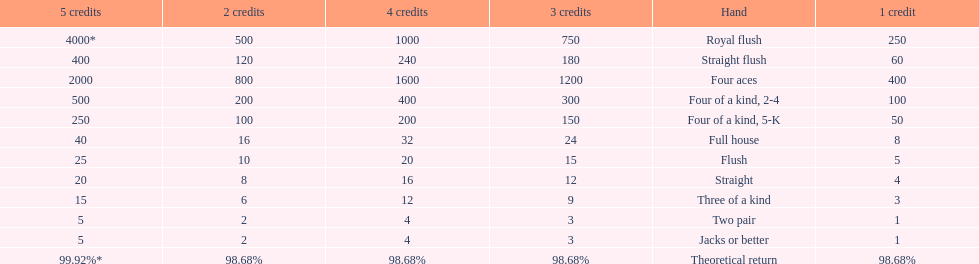What are the different hands? Royal flush, Straight flush, Four aces, Four of a kind, 2-4, Four of a kind, 5-K, Full house, Flush, Straight, Three of a kind, Two pair, Jacks or better. Which hands have a higher standing than a straight? Royal flush, Straight flush, Four aces, Four of a kind, 2-4, Four of a kind, 5-K, Full house, Flush. Of these, which hand is the next highest after a straight? Flush. 